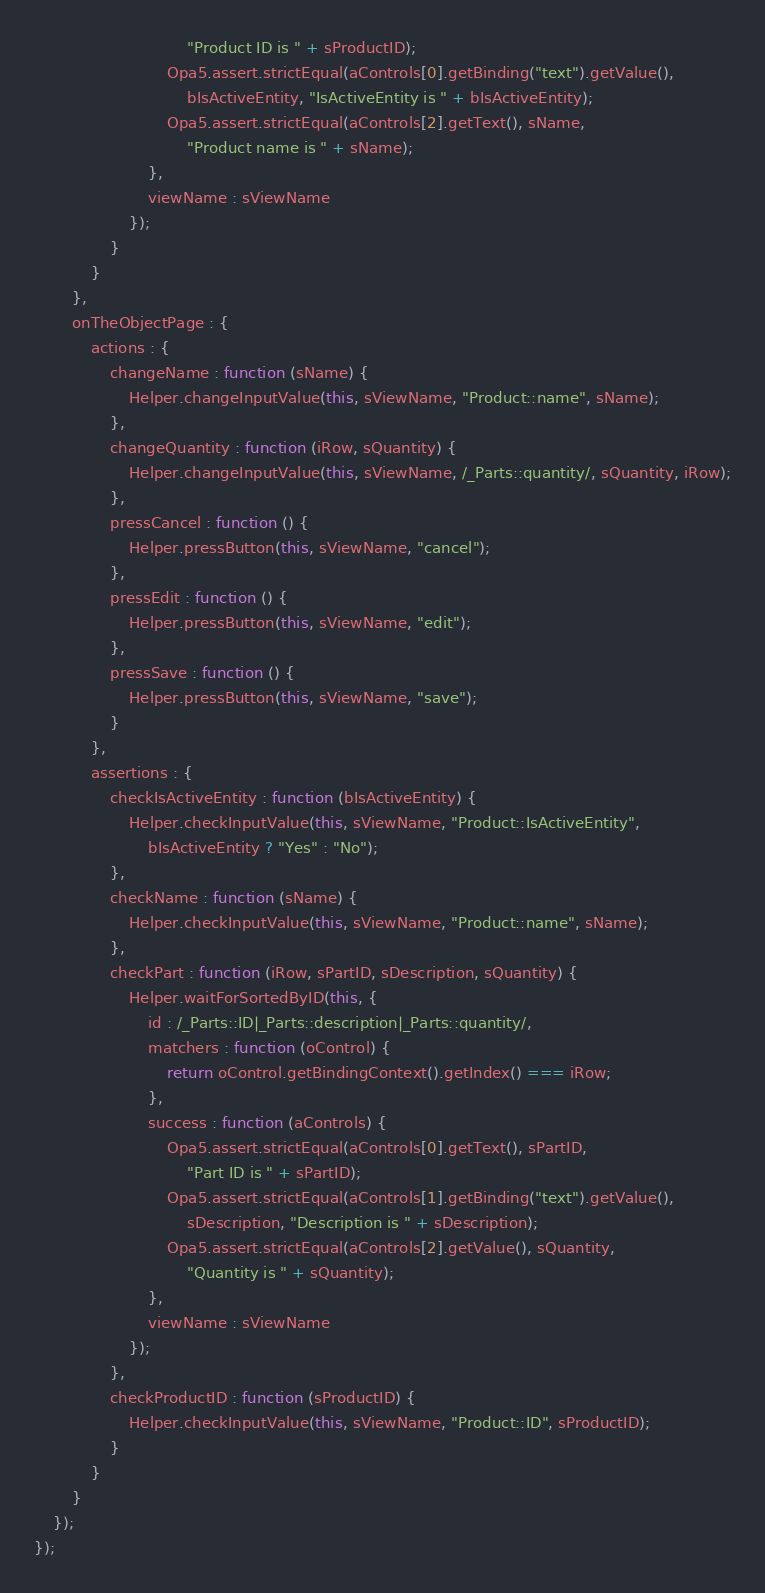<code> <loc_0><loc_0><loc_500><loc_500><_JavaScript_>								"Product ID is " + sProductID);
							Opa5.assert.strictEqual(aControls[0].getBinding("text").getValue(),
								bIsActiveEntity, "IsActiveEntity is " + bIsActiveEntity);
							Opa5.assert.strictEqual(aControls[2].getText(), sName,
								"Product name is " + sName);
						},
						viewName : sViewName
					});
				}
			}
		},
		onTheObjectPage : {
			actions : {
				changeName : function (sName) {
					Helper.changeInputValue(this, sViewName, "Product::name", sName);
				},
				changeQuantity : function (iRow, sQuantity) {
					Helper.changeInputValue(this, sViewName, /_Parts::quantity/, sQuantity, iRow);
				},
				pressCancel : function () {
					Helper.pressButton(this, sViewName, "cancel");
				},
				pressEdit : function () {
					Helper.pressButton(this, sViewName, "edit");
				},
				pressSave : function () {
					Helper.pressButton(this, sViewName, "save");
				}
			},
			assertions : {
				checkIsActiveEntity : function (bIsActiveEntity) {
					Helper.checkInputValue(this, sViewName, "Product::IsActiveEntity",
						bIsActiveEntity ? "Yes" : "No");
				},
				checkName : function (sName) {
					Helper.checkInputValue(this, sViewName, "Product::name", sName);
				},
				checkPart : function (iRow, sPartID, sDescription, sQuantity) {
					Helper.waitForSortedByID(this, {
						id : /_Parts::ID|_Parts::description|_Parts::quantity/,
						matchers : function (oControl) {
							return oControl.getBindingContext().getIndex() === iRow;
						},
						success : function (aControls) {
							Opa5.assert.strictEqual(aControls[0].getText(), sPartID,
								"Part ID is " + sPartID);
							Opa5.assert.strictEqual(aControls[1].getBinding("text").getValue(),
								sDescription, "Description is " + sDescription);
							Opa5.assert.strictEqual(aControls[2].getValue(), sQuantity,
								"Quantity is " + sQuantity);
						},
						viewName : sViewName
					});
				},
				checkProductID : function (sProductID) {
					Helper.checkInputValue(this, sViewName, "Product::ID", sProductID);
				}
			}
		}
	});
});
</code> 